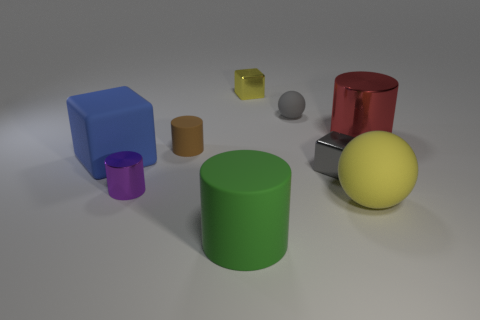Subtract 1 blue blocks. How many objects are left? 8 Subtract all cubes. How many objects are left? 6 Subtract 2 balls. How many balls are left? 0 Subtract all blue balls. Subtract all gray blocks. How many balls are left? 2 Subtract all green cylinders. How many blue blocks are left? 1 Subtract all large yellow objects. Subtract all big rubber balls. How many objects are left? 7 Add 5 gray matte things. How many gray matte things are left? 6 Add 3 tiny metallic objects. How many tiny metallic objects exist? 6 Add 1 small yellow metallic cubes. How many objects exist? 10 Subtract all green cylinders. How many cylinders are left? 3 